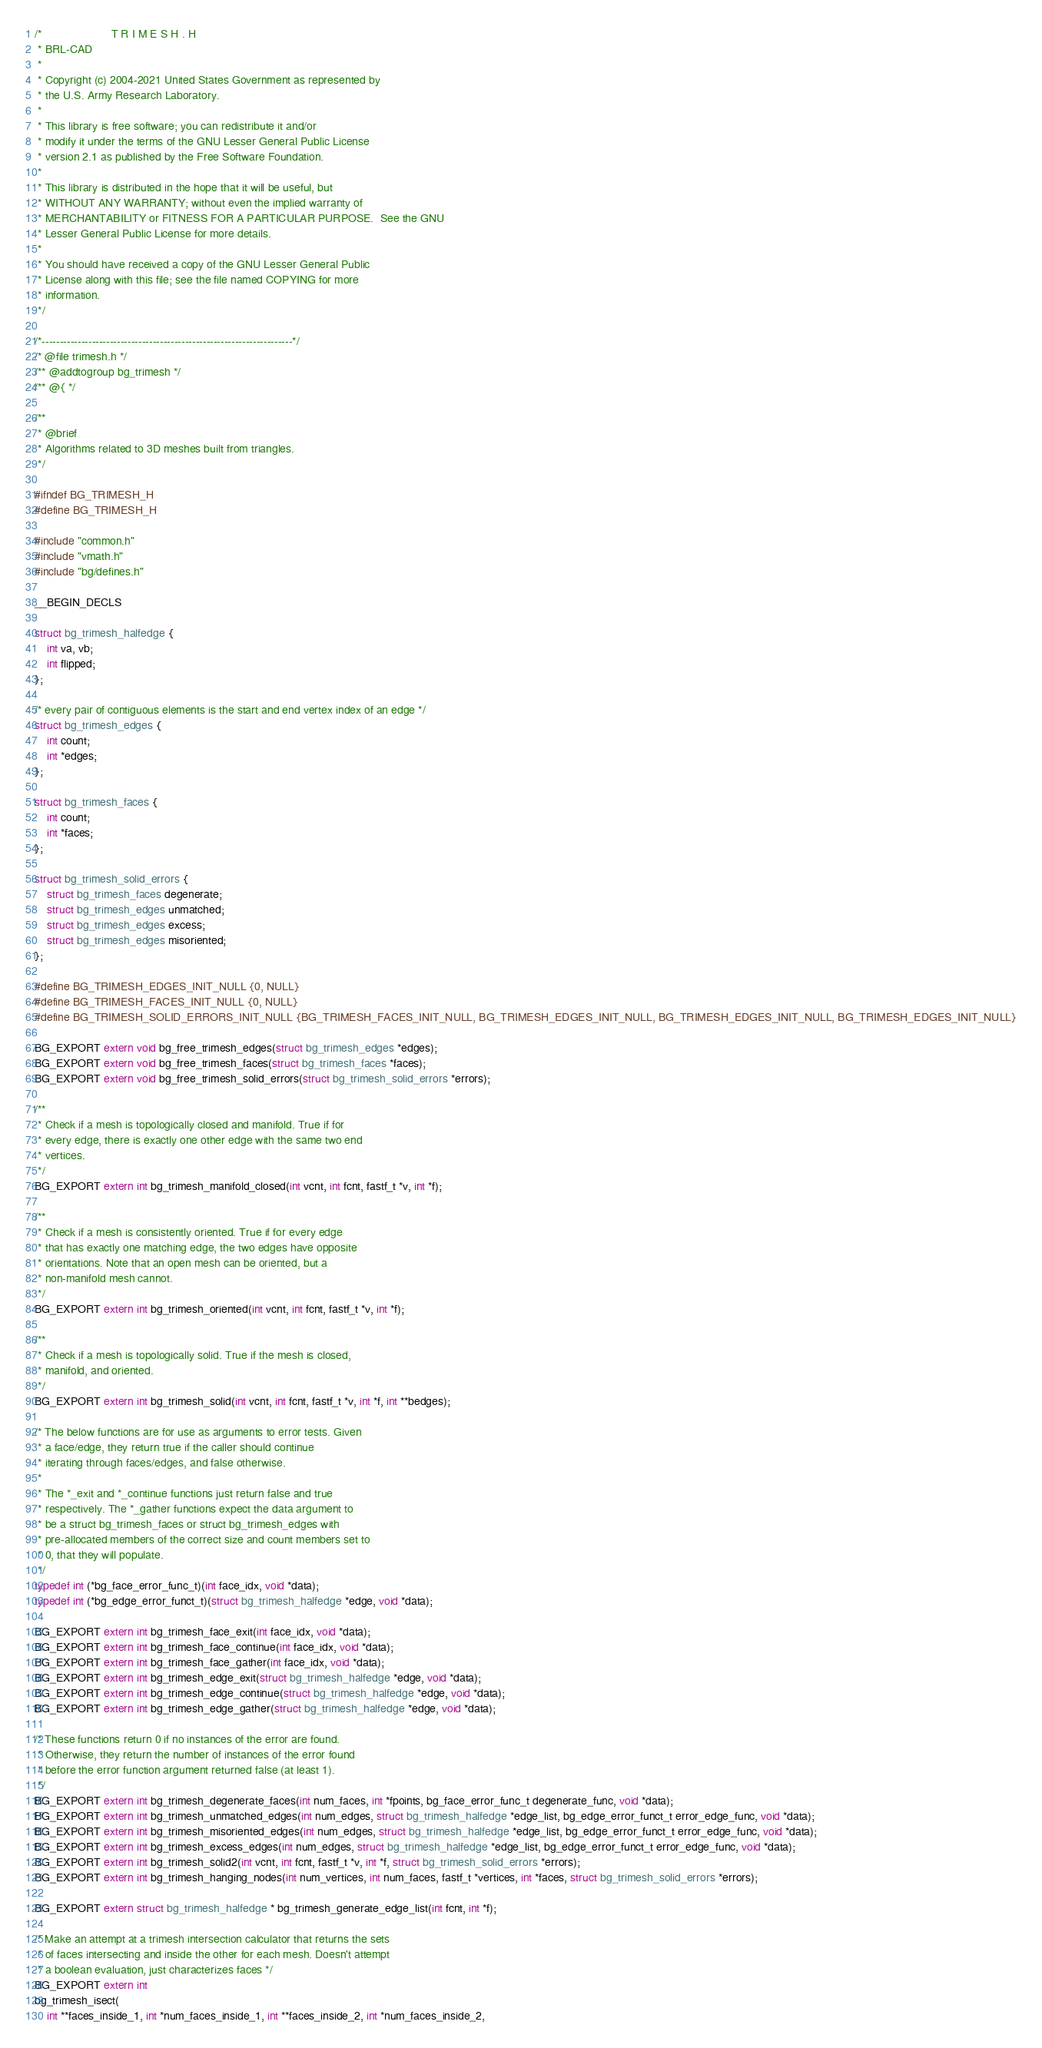<code> <loc_0><loc_0><loc_500><loc_500><_C_>/*                      T R I M E S H . H
 * BRL-CAD
 *
 * Copyright (c) 2004-2021 United States Government as represented by
 * the U.S. Army Research Laboratory.
 *
 * This library is free software; you can redistribute it and/or
 * modify it under the terms of the GNU Lesser General Public License
 * version 2.1 as published by the Free Software Foundation.
 *
 * This library is distributed in the hope that it will be useful, but
 * WITHOUT ANY WARRANTY; without even the implied warranty of
 * MERCHANTABILITY or FITNESS FOR A PARTICULAR PURPOSE.  See the GNU
 * Lesser General Public License for more details.
 *
 * You should have received a copy of the GNU Lesser General Public
 * License along with this file; see the file named COPYING for more
 * information.
 */

/*----------------------------------------------------------------------*/
/* @file trimesh.h */
/** @addtogroup bg_trimesh */
/** @{ */

/**
 * @brief
 * Algorithms related to 3D meshes built from triangles.
 */

#ifndef BG_TRIMESH_H
#define BG_TRIMESH_H

#include "common.h"
#include "vmath.h"
#include "bg/defines.h"

__BEGIN_DECLS

struct bg_trimesh_halfedge {
    int va, vb;
    int flipped;
};

/* every pair of contiguous elements is the start and end vertex index of an edge */
struct bg_trimesh_edges {
    int count;
    int *edges;
};

struct bg_trimesh_faces {
    int count;
    int *faces;
};

struct bg_trimesh_solid_errors {
    struct bg_trimesh_faces degenerate;
    struct bg_trimesh_edges unmatched;
    struct bg_trimesh_edges excess;
    struct bg_trimesh_edges misoriented;
};

#define BG_TRIMESH_EDGES_INIT_NULL {0, NULL}
#define BG_TRIMESH_FACES_INIT_NULL {0, NULL}
#define BG_TRIMESH_SOLID_ERRORS_INIT_NULL {BG_TRIMESH_FACES_INIT_NULL, BG_TRIMESH_EDGES_INIT_NULL, BG_TRIMESH_EDGES_INIT_NULL, BG_TRIMESH_EDGES_INIT_NULL}

BG_EXPORT extern void bg_free_trimesh_edges(struct bg_trimesh_edges *edges);
BG_EXPORT extern void bg_free_trimesh_faces(struct bg_trimesh_faces *faces);
BG_EXPORT extern void bg_free_trimesh_solid_errors(struct bg_trimesh_solid_errors *errors);

/**
 * Check if a mesh is topologically closed and manifold. True if for
 * every edge, there is exactly one other edge with the same two end
 * vertices.
 */
BG_EXPORT extern int bg_trimesh_manifold_closed(int vcnt, int fcnt, fastf_t *v, int *f);

/**
 * Check if a mesh is consistently oriented. True if for every edge
 * that has exactly one matching edge, the two edges have opposite
 * orientations. Note that an open mesh can be oriented, but a
 * non-manifold mesh cannot.
 */
BG_EXPORT extern int bg_trimesh_oriented(int vcnt, int fcnt, fastf_t *v, int *f);

/**
 * Check if a mesh is topologically solid. True if the mesh is closed,
 * manifold, and oriented.
 */
BG_EXPORT extern int bg_trimesh_solid(int vcnt, int fcnt, fastf_t *v, int *f, int **bedges);

/* The below functions are for use as arguments to error tests. Given
 * a face/edge, they return true if the caller should continue
 * iterating through faces/edges, and false otherwise.
 *
 * The *_exit and *_continue functions just return false and true
 * respectively. The *_gather functions expect the data argument to
 * be a struct bg_trimesh_faces or struct bg_trimesh_edges with
 * pre-allocated members of the correct size and count members set to
 * 0, that they will populate.
 */
typedef int (*bg_face_error_func_t)(int face_idx, void *data);
typedef int (*bg_edge_error_funct_t)(struct bg_trimesh_halfedge *edge, void *data);

BG_EXPORT extern int bg_trimesh_face_exit(int face_idx, void *data);
BG_EXPORT extern int bg_trimesh_face_continue(int face_idx, void *data);
BG_EXPORT extern int bg_trimesh_face_gather(int face_idx, void *data);
BG_EXPORT extern int bg_trimesh_edge_exit(struct bg_trimesh_halfedge *edge, void *data);
BG_EXPORT extern int bg_trimesh_edge_continue(struct bg_trimesh_halfedge *edge, void *data);
BG_EXPORT extern int bg_trimesh_edge_gather(struct bg_trimesh_halfedge *edge, void *data);

/* These functions return 0 if no instances of the error are found.
 * Otherwise, they return the number of instances of the error found
 * before the error function argument returned false (at least 1).
 */
BG_EXPORT extern int bg_trimesh_degenerate_faces(int num_faces, int *fpoints, bg_face_error_func_t degenerate_func, void *data);
BG_EXPORT extern int bg_trimesh_unmatched_edges(int num_edges, struct bg_trimesh_halfedge *edge_list, bg_edge_error_funct_t error_edge_func, void *data);
BG_EXPORT extern int bg_trimesh_misoriented_edges(int num_edges, struct bg_trimesh_halfedge *edge_list, bg_edge_error_funct_t error_edge_func, void *data);
BG_EXPORT extern int bg_trimesh_excess_edges(int num_edges, struct bg_trimesh_halfedge *edge_list, bg_edge_error_funct_t error_edge_func, void *data);
BG_EXPORT extern int bg_trimesh_solid2(int vcnt, int fcnt, fastf_t *v, int *f, struct bg_trimesh_solid_errors *errors);
BG_EXPORT extern int bg_trimesh_hanging_nodes(int num_vertices, int num_faces, fastf_t *vertices, int *faces, struct bg_trimesh_solid_errors *errors);

BG_EXPORT extern struct bg_trimesh_halfedge * bg_trimesh_generate_edge_list(int fcnt, int *f);

/* Make an attempt at a trimesh intersection calculator that returns the sets
 * of faces intersecting and inside the other for each mesh. Doesn't attempt
 * a boolean evaluation, just characterizes faces */
BG_EXPORT extern int
bg_trimesh_isect(
    int **faces_inside_1, int *num_faces_inside_1, int **faces_inside_2, int *num_faces_inside_2,</code> 